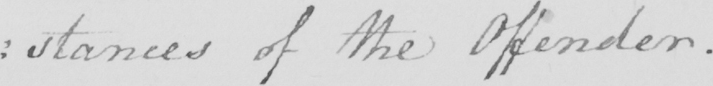What text is written in this handwritten line? : stances of the Offender . 